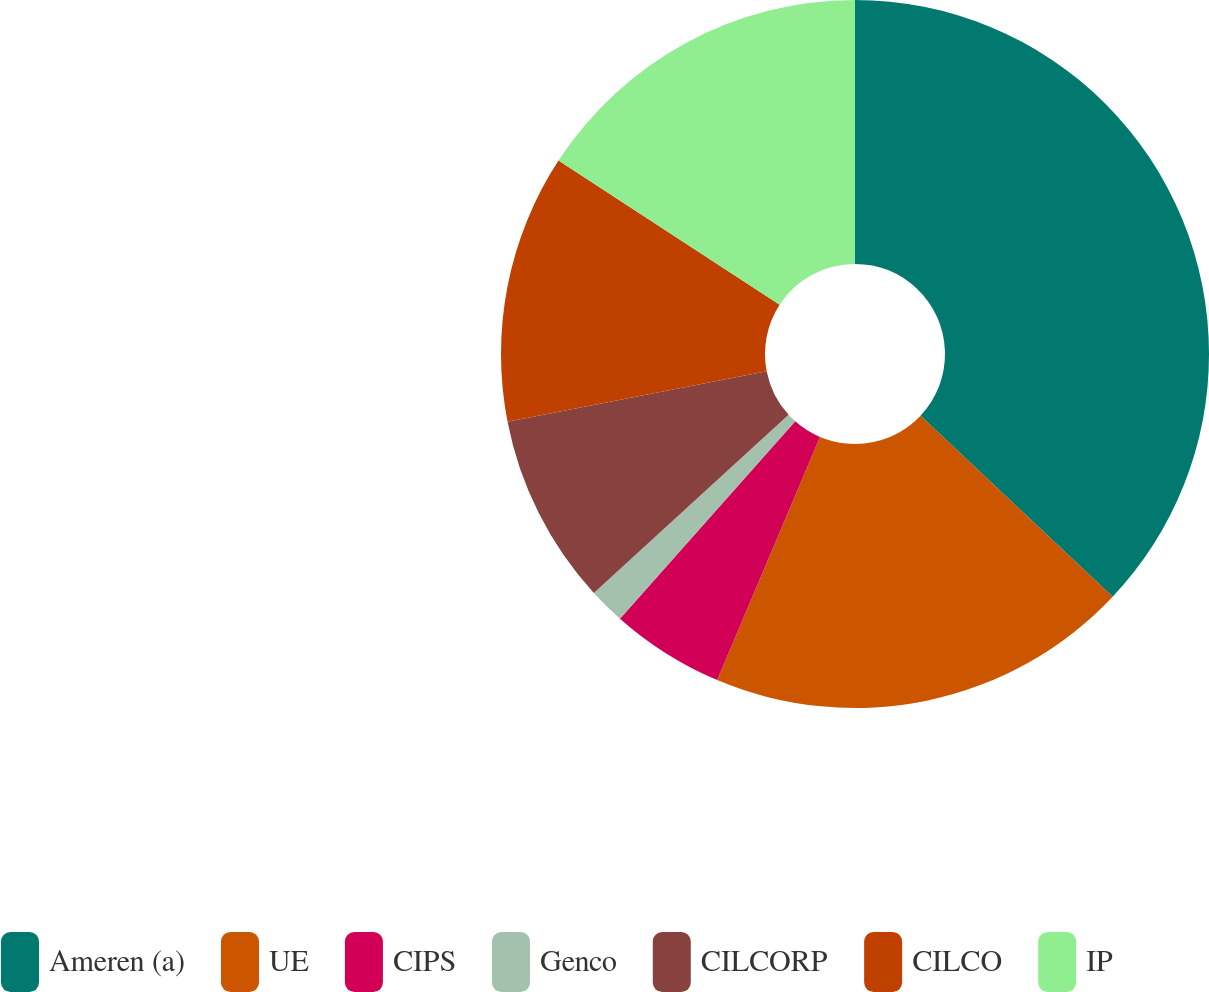Convert chart. <chart><loc_0><loc_0><loc_500><loc_500><pie_chart><fcel>Ameren (a)<fcel>UE<fcel>CIPS<fcel>Genco<fcel>CILCORP<fcel>CILCO<fcel>IP<nl><fcel>37.02%<fcel>19.34%<fcel>5.19%<fcel>1.65%<fcel>8.73%<fcel>12.26%<fcel>15.8%<nl></chart> 